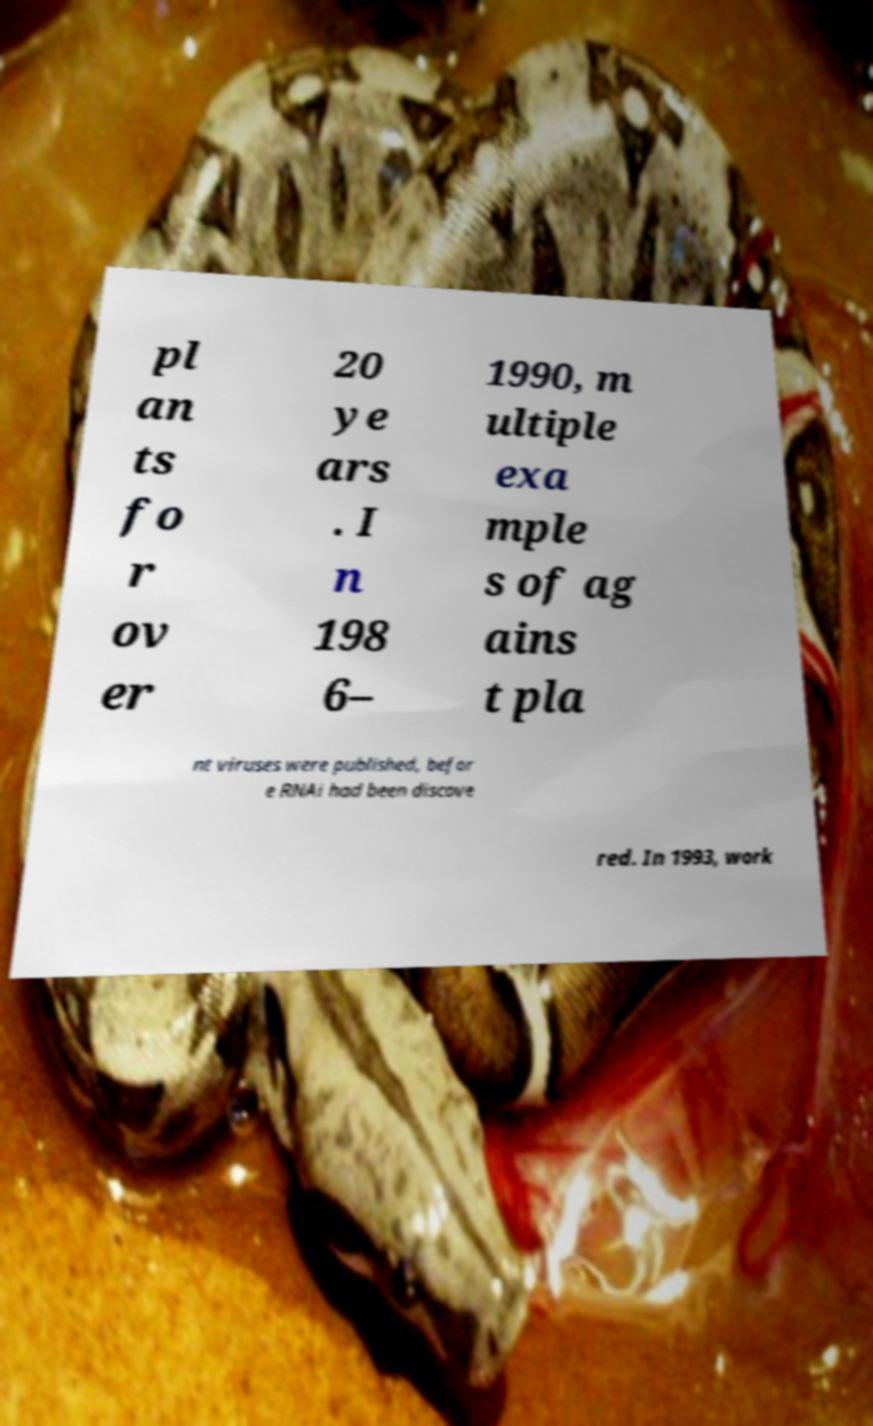Can you accurately transcribe the text from the provided image for me? pl an ts fo r ov er 20 ye ars . I n 198 6– 1990, m ultiple exa mple s of ag ains t pla nt viruses were published, befor e RNAi had been discove red. In 1993, work 